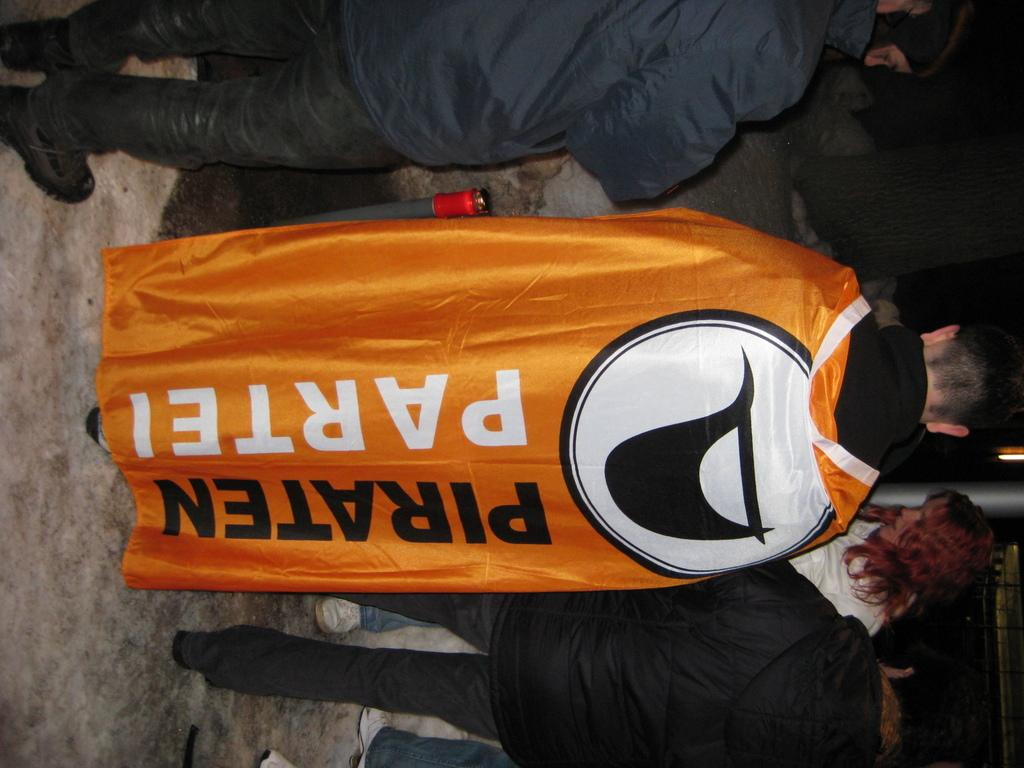<image>
Create a compact narrative representing the image presented. A man is wearing an orange cape that says "Piraten Partei" 